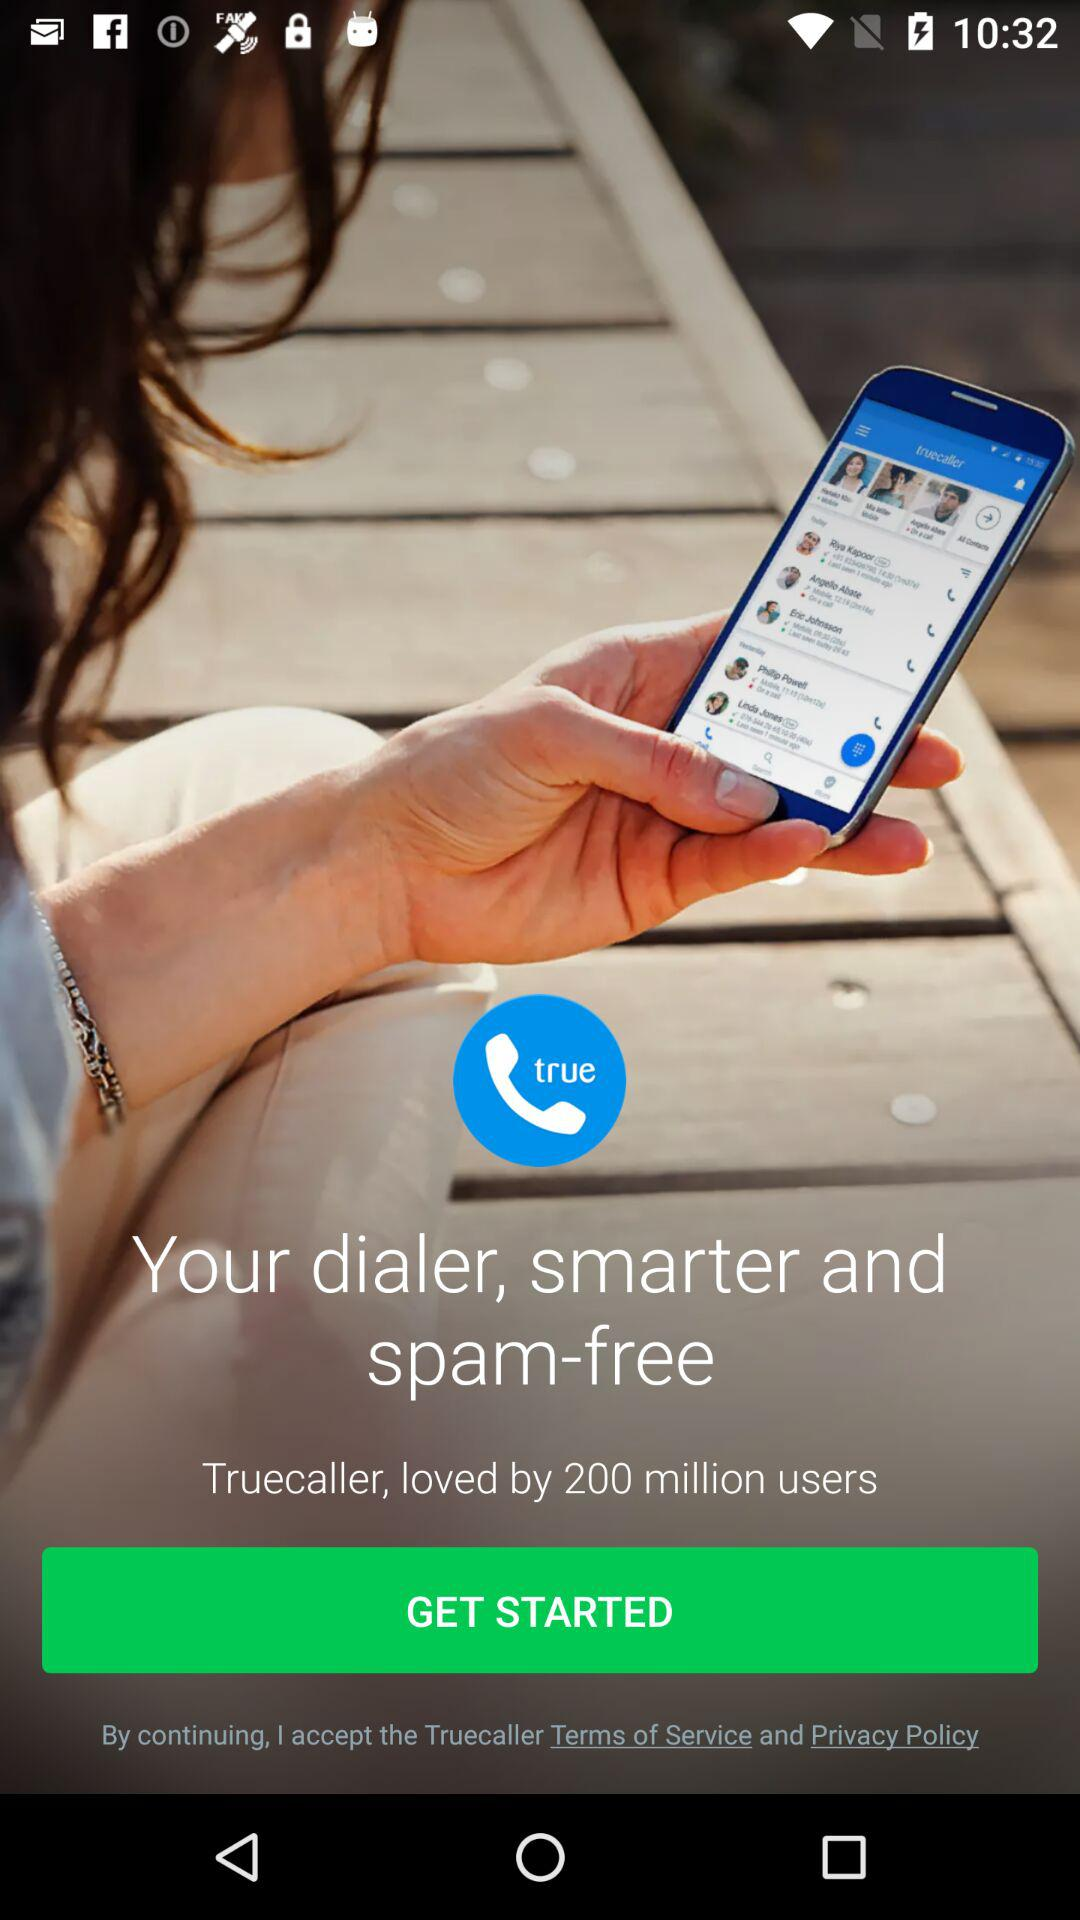How many reviews does "Truecaller" have?
When the provided information is insufficient, respond with <no answer>. <no answer> 